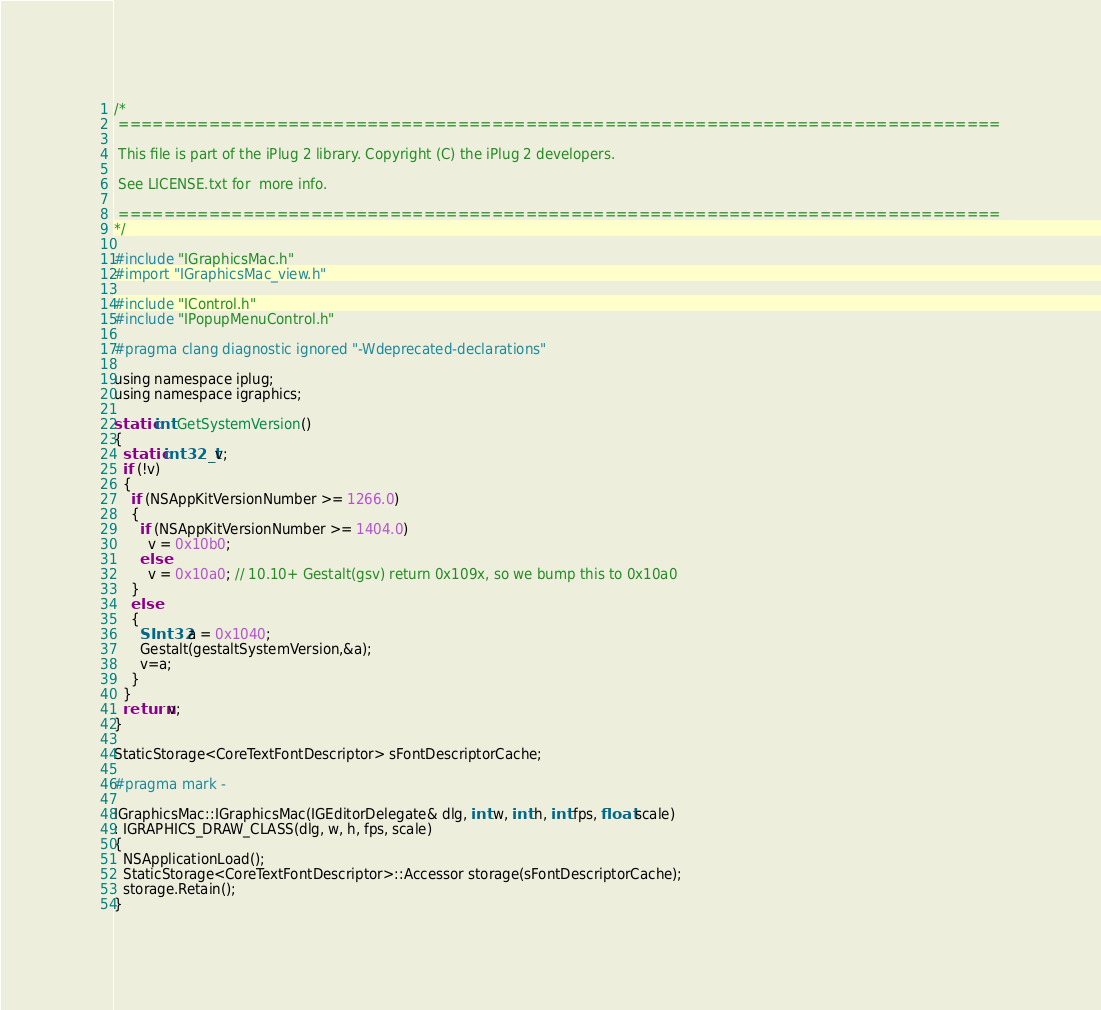<code> <loc_0><loc_0><loc_500><loc_500><_ObjectiveC_>/*
 ==============================================================================

 This file is part of the iPlug 2 library. Copyright (C) the iPlug 2 developers.

 See LICENSE.txt for  more info.

 ==============================================================================
*/

#include "IGraphicsMac.h"
#import "IGraphicsMac_view.h"

#include "IControl.h"
#include "IPopupMenuControl.h"

#pragma clang diagnostic ignored "-Wdeprecated-declarations"

using namespace iplug;
using namespace igraphics;

static int GetSystemVersion()
{
  static int32_t v;
  if (!v)
  {
    if (NSAppKitVersionNumber >= 1266.0)
    {
      if (NSAppKitVersionNumber >= 1404.0)
        v = 0x10b0;
      else
        v = 0x10a0; // 10.10+ Gestalt(gsv) return 0x109x, so we bump this to 0x10a0
    }
    else
    {
      SInt32 a = 0x1040;
      Gestalt(gestaltSystemVersion,&a);
      v=a;
    }
  }
  return v;
}

StaticStorage<CoreTextFontDescriptor> sFontDescriptorCache;

#pragma mark -

IGraphicsMac::IGraphicsMac(IGEditorDelegate& dlg, int w, int h, int fps, float scale)
: IGRAPHICS_DRAW_CLASS(dlg, w, h, fps, scale)
{
  NSApplicationLoad();
  StaticStorage<CoreTextFontDescriptor>::Accessor storage(sFontDescriptorCache);
  storage.Retain();
}
</code> 